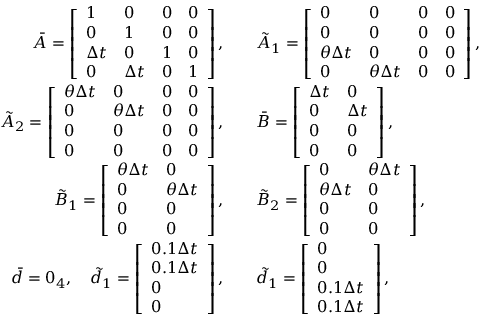Convert formula to latex. <formula><loc_0><loc_0><loc_500><loc_500>\begin{array} { r l } { \bar { A } = \left [ \begin{array} { l l l l } { 1 } & { 0 } & { 0 } & { 0 } \\ { 0 } & { 1 } & { 0 } & { 0 } \\ { \Delta t } & { 0 } & { 1 } & { 0 } \\ { 0 } & { \Delta t } & { 0 } & { 1 } \end{array} \right ] , } & { \quad \tilde { A } _ { 1 } = \left [ \begin{array} { l l l l } { 0 } & { 0 } & { 0 } & { 0 } \\ { 0 } & { 0 } & { 0 } & { 0 } \\ { \theta \Delta t } & { 0 } & { 0 } & { 0 } \\ { 0 } & { \theta \Delta t } & { 0 } & { 0 } \end{array} \right ] , } \\ { \tilde { A } _ { 2 } = \left [ \begin{array} { l l l l } { \theta \Delta t } & { 0 } & { 0 } & { 0 } \\ { 0 } & { \theta \Delta t } & { 0 } & { 0 } \\ { 0 } & { 0 } & { 0 } & { 0 } \\ { 0 } & { 0 } & { 0 } & { 0 } \end{array} \right ] , } & { \quad \bar { B } = \left [ \begin{array} { l l } { \Delta t } & { 0 } \\ { 0 } & { \Delta t } \\ { 0 } & { 0 } \\ { 0 } & { 0 } \end{array} \right ] , } \\ { \tilde { B } _ { 1 } = \left [ \begin{array} { l l } { \theta \Delta t } & { 0 } \\ { 0 } & { \theta \Delta t } \\ { 0 } & { 0 } \\ { 0 } & { 0 } \end{array} \right ] , } & { \quad \tilde { B } _ { 2 } = \left [ \begin{array} { l l } { 0 } & { \theta \Delta t } \\ { \theta \Delta t } & { 0 } \\ { 0 } & { 0 } \\ { 0 } & { 0 } \end{array} \right ] , } \\ { \bar { d } = 0 _ { 4 } , \quad \tilde { d } _ { 1 } = \left [ \begin{array} { l } { 0 . 1 \Delta t } \\ { 0 . 1 \Delta t } \\ { 0 } \\ { 0 } \end{array} \right ] , } & { \quad \tilde { d } _ { 1 } = \left [ \begin{array} { l } { 0 } \\ { 0 } \\ { 0 . 1 \Delta t } \\ { 0 . 1 \Delta t } \end{array} \right ] , } \end{array}</formula> 